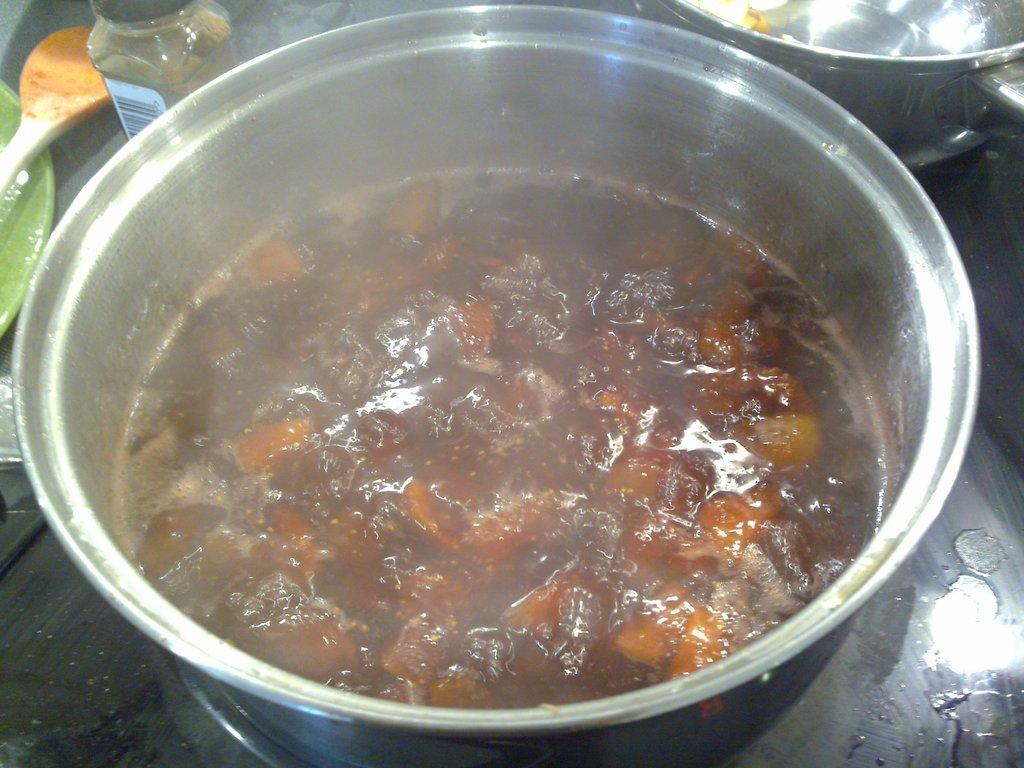Could you give a brief overview of what you see in this image? In the foreground of this image, there is a vessel on a stove in which, there is some food. At the top, there is another vessel and a bottle. On the left, there is a plate and a spoon. 